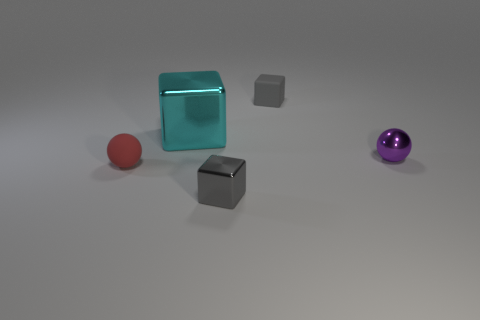How many other objects are the same material as the small purple object?
Keep it short and to the point. 2. There is a gray object behind the tiny red matte ball; is it the same size as the metallic block that is behind the tiny red matte ball?
Your answer should be compact. No. What number of objects are tiny metallic things on the right side of the small shiny block or tiny rubber objects in front of the big cyan shiny block?
Your answer should be very brief. 2. Is there any other thing that is the same shape as the tiny gray metallic thing?
Give a very brief answer. Yes. There is a ball to the left of the cyan shiny block; is it the same color as the rubber object that is to the right of the big cyan cube?
Give a very brief answer. No. How many rubber objects are purple things or red things?
Keep it short and to the point. 1. Is there any other thing that is the same size as the purple metallic ball?
Your response must be concise. Yes. There is a shiny object that is on the right side of the tiny block that is in front of the large block; what shape is it?
Provide a short and direct response. Sphere. Is the material of the gray block behind the big object the same as the small block in front of the small purple ball?
Give a very brief answer. No. There is a small gray object to the right of the tiny gray metal cube; how many purple metal objects are on the left side of it?
Ensure brevity in your answer.  0. 